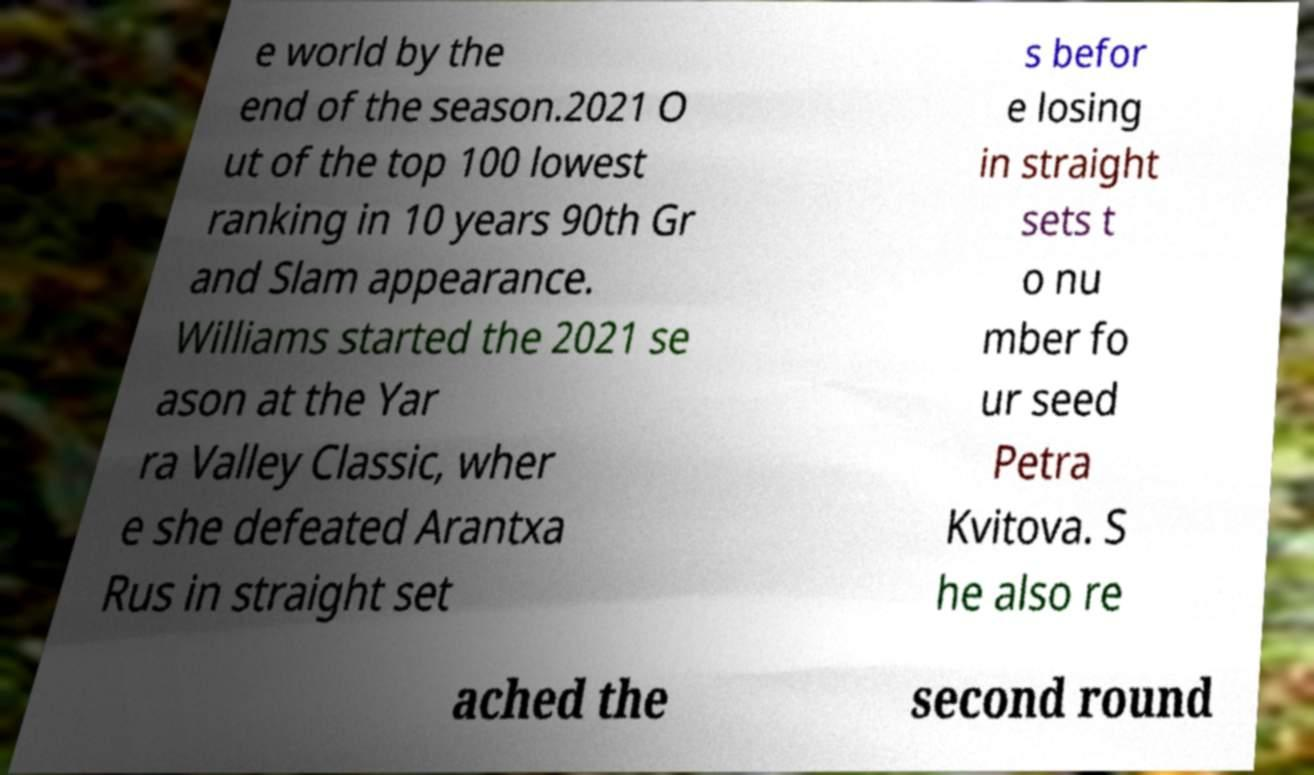Could you extract and type out the text from this image? e world by the end of the season.2021 O ut of the top 100 lowest ranking in 10 years 90th Gr and Slam appearance. Williams started the 2021 se ason at the Yar ra Valley Classic, wher e she defeated Arantxa Rus in straight set s befor e losing in straight sets t o nu mber fo ur seed Petra Kvitova. S he also re ached the second round 